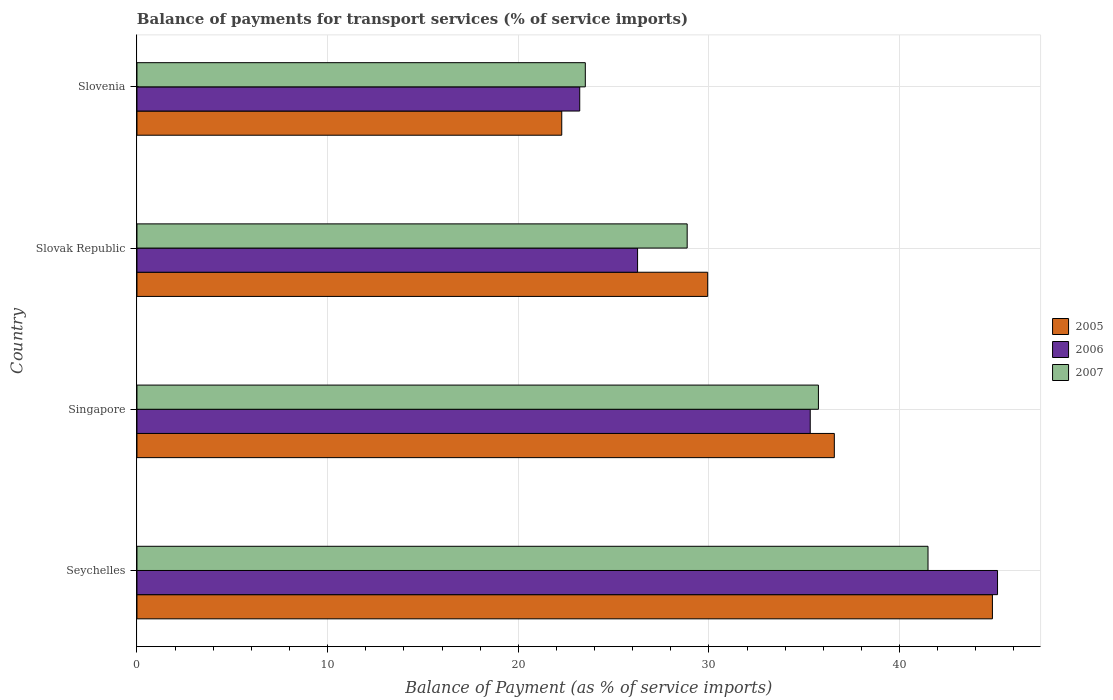How many different coloured bars are there?
Provide a short and direct response. 3. Are the number of bars per tick equal to the number of legend labels?
Offer a terse response. Yes. Are the number of bars on each tick of the Y-axis equal?
Provide a short and direct response. Yes. How many bars are there on the 4th tick from the top?
Offer a very short reply. 3. What is the label of the 1st group of bars from the top?
Your answer should be very brief. Slovenia. In how many cases, is the number of bars for a given country not equal to the number of legend labels?
Make the answer very short. 0. What is the balance of payments for transport services in 2007 in Singapore?
Your answer should be very brief. 35.74. Across all countries, what is the maximum balance of payments for transport services in 2006?
Ensure brevity in your answer.  45.14. Across all countries, what is the minimum balance of payments for transport services in 2007?
Provide a short and direct response. 23.52. In which country was the balance of payments for transport services in 2006 maximum?
Your answer should be very brief. Seychelles. In which country was the balance of payments for transport services in 2006 minimum?
Provide a short and direct response. Slovenia. What is the total balance of payments for transport services in 2007 in the graph?
Give a very brief answer. 129.61. What is the difference between the balance of payments for transport services in 2005 in Seychelles and that in Singapore?
Your response must be concise. 8.29. What is the difference between the balance of payments for transport services in 2005 in Slovak Republic and the balance of payments for transport services in 2006 in Slovenia?
Keep it short and to the point. 6.71. What is the average balance of payments for transport services in 2005 per country?
Offer a terse response. 33.42. What is the difference between the balance of payments for transport services in 2007 and balance of payments for transport services in 2006 in Singapore?
Ensure brevity in your answer.  0.43. In how many countries, is the balance of payments for transport services in 2007 greater than 14 %?
Offer a very short reply. 4. What is the ratio of the balance of payments for transport services in 2006 in Slovak Republic to that in Slovenia?
Your answer should be very brief. 1.13. What is the difference between the highest and the second highest balance of payments for transport services in 2006?
Provide a succinct answer. 9.82. What is the difference between the highest and the lowest balance of payments for transport services in 2005?
Provide a short and direct response. 22.59. In how many countries, is the balance of payments for transport services in 2006 greater than the average balance of payments for transport services in 2006 taken over all countries?
Ensure brevity in your answer.  2. Is it the case that in every country, the sum of the balance of payments for transport services in 2006 and balance of payments for transport services in 2007 is greater than the balance of payments for transport services in 2005?
Your answer should be very brief. Yes. How many countries are there in the graph?
Provide a short and direct response. 4. Where does the legend appear in the graph?
Keep it short and to the point. Center right. How are the legend labels stacked?
Make the answer very short. Vertical. What is the title of the graph?
Keep it short and to the point. Balance of payments for transport services (% of service imports). What is the label or title of the X-axis?
Offer a very short reply. Balance of Payment (as % of service imports). What is the Balance of Payment (as % of service imports) of 2005 in Seychelles?
Your answer should be compact. 44.87. What is the Balance of Payment (as % of service imports) in 2006 in Seychelles?
Your answer should be compact. 45.14. What is the Balance of Payment (as % of service imports) in 2007 in Seychelles?
Your response must be concise. 41.49. What is the Balance of Payment (as % of service imports) in 2005 in Singapore?
Your answer should be very brief. 36.58. What is the Balance of Payment (as % of service imports) in 2006 in Singapore?
Keep it short and to the point. 35.31. What is the Balance of Payment (as % of service imports) of 2007 in Singapore?
Provide a short and direct response. 35.74. What is the Balance of Payment (as % of service imports) of 2005 in Slovak Republic?
Ensure brevity in your answer.  29.93. What is the Balance of Payment (as % of service imports) in 2006 in Slovak Republic?
Make the answer very short. 26.26. What is the Balance of Payment (as % of service imports) of 2007 in Slovak Republic?
Offer a very short reply. 28.86. What is the Balance of Payment (as % of service imports) of 2005 in Slovenia?
Ensure brevity in your answer.  22.28. What is the Balance of Payment (as % of service imports) of 2006 in Slovenia?
Offer a terse response. 23.22. What is the Balance of Payment (as % of service imports) in 2007 in Slovenia?
Offer a terse response. 23.52. Across all countries, what is the maximum Balance of Payment (as % of service imports) of 2005?
Ensure brevity in your answer.  44.87. Across all countries, what is the maximum Balance of Payment (as % of service imports) in 2006?
Your answer should be compact. 45.14. Across all countries, what is the maximum Balance of Payment (as % of service imports) in 2007?
Your answer should be compact. 41.49. Across all countries, what is the minimum Balance of Payment (as % of service imports) in 2005?
Give a very brief answer. 22.28. Across all countries, what is the minimum Balance of Payment (as % of service imports) in 2006?
Your answer should be very brief. 23.22. Across all countries, what is the minimum Balance of Payment (as % of service imports) in 2007?
Your answer should be very brief. 23.52. What is the total Balance of Payment (as % of service imports) in 2005 in the graph?
Ensure brevity in your answer.  133.66. What is the total Balance of Payment (as % of service imports) of 2006 in the graph?
Provide a short and direct response. 129.93. What is the total Balance of Payment (as % of service imports) in 2007 in the graph?
Offer a very short reply. 129.61. What is the difference between the Balance of Payment (as % of service imports) of 2005 in Seychelles and that in Singapore?
Offer a terse response. 8.29. What is the difference between the Balance of Payment (as % of service imports) in 2006 in Seychelles and that in Singapore?
Ensure brevity in your answer.  9.82. What is the difference between the Balance of Payment (as % of service imports) of 2007 in Seychelles and that in Singapore?
Keep it short and to the point. 5.75. What is the difference between the Balance of Payment (as % of service imports) of 2005 in Seychelles and that in Slovak Republic?
Ensure brevity in your answer.  14.94. What is the difference between the Balance of Payment (as % of service imports) in 2006 in Seychelles and that in Slovak Republic?
Provide a short and direct response. 18.88. What is the difference between the Balance of Payment (as % of service imports) of 2007 in Seychelles and that in Slovak Republic?
Your response must be concise. 12.63. What is the difference between the Balance of Payment (as % of service imports) of 2005 in Seychelles and that in Slovenia?
Provide a short and direct response. 22.59. What is the difference between the Balance of Payment (as % of service imports) of 2006 in Seychelles and that in Slovenia?
Provide a succinct answer. 21.91. What is the difference between the Balance of Payment (as % of service imports) of 2007 in Seychelles and that in Slovenia?
Offer a terse response. 17.98. What is the difference between the Balance of Payment (as % of service imports) of 2005 in Singapore and that in Slovak Republic?
Your answer should be very brief. 6.64. What is the difference between the Balance of Payment (as % of service imports) in 2006 in Singapore and that in Slovak Republic?
Offer a very short reply. 9.06. What is the difference between the Balance of Payment (as % of service imports) in 2007 in Singapore and that in Slovak Republic?
Your answer should be very brief. 6.88. What is the difference between the Balance of Payment (as % of service imports) in 2005 in Singapore and that in Slovenia?
Keep it short and to the point. 14.3. What is the difference between the Balance of Payment (as % of service imports) of 2006 in Singapore and that in Slovenia?
Make the answer very short. 12.09. What is the difference between the Balance of Payment (as % of service imports) of 2007 in Singapore and that in Slovenia?
Your answer should be compact. 12.23. What is the difference between the Balance of Payment (as % of service imports) in 2005 in Slovak Republic and that in Slovenia?
Give a very brief answer. 7.65. What is the difference between the Balance of Payment (as % of service imports) in 2006 in Slovak Republic and that in Slovenia?
Your response must be concise. 3.03. What is the difference between the Balance of Payment (as % of service imports) in 2007 in Slovak Republic and that in Slovenia?
Provide a succinct answer. 5.34. What is the difference between the Balance of Payment (as % of service imports) in 2005 in Seychelles and the Balance of Payment (as % of service imports) in 2006 in Singapore?
Provide a succinct answer. 9.56. What is the difference between the Balance of Payment (as % of service imports) in 2005 in Seychelles and the Balance of Payment (as % of service imports) in 2007 in Singapore?
Make the answer very short. 9.13. What is the difference between the Balance of Payment (as % of service imports) of 2006 in Seychelles and the Balance of Payment (as % of service imports) of 2007 in Singapore?
Your answer should be very brief. 9.39. What is the difference between the Balance of Payment (as % of service imports) in 2005 in Seychelles and the Balance of Payment (as % of service imports) in 2006 in Slovak Republic?
Your answer should be compact. 18.61. What is the difference between the Balance of Payment (as % of service imports) of 2005 in Seychelles and the Balance of Payment (as % of service imports) of 2007 in Slovak Republic?
Offer a terse response. 16.01. What is the difference between the Balance of Payment (as % of service imports) in 2006 in Seychelles and the Balance of Payment (as % of service imports) in 2007 in Slovak Republic?
Your answer should be compact. 16.28. What is the difference between the Balance of Payment (as % of service imports) of 2005 in Seychelles and the Balance of Payment (as % of service imports) of 2006 in Slovenia?
Your response must be concise. 21.65. What is the difference between the Balance of Payment (as % of service imports) of 2005 in Seychelles and the Balance of Payment (as % of service imports) of 2007 in Slovenia?
Offer a very short reply. 21.35. What is the difference between the Balance of Payment (as % of service imports) of 2006 in Seychelles and the Balance of Payment (as % of service imports) of 2007 in Slovenia?
Your response must be concise. 21.62. What is the difference between the Balance of Payment (as % of service imports) of 2005 in Singapore and the Balance of Payment (as % of service imports) of 2006 in Slovak Republic?
Ensure brevity in your answer.  10.32. What is the difference between the Balance of Payment (as % of service imports) of 2005 in Singapore and the Balance of Payment (as % of service imports) of 2007 in Slovak Republic?
Ensure brevity in your answer.  7.72. What is the difference between the Balance of Payment (as % of service imports) of 2006 in Singapore and the Balance of Payment (as % of service imports) of 2007 in Slovak Republic?
Provide a succinct answer. 6.46. What is the difference between the Balance of Payment (as % of service imports) of 2005 in Singapore and the Balance of Payment (as % of service imports) of 2006 in Slovenia?
Provide a short and direct response. 13.35. What is the difference between the Balance of Payment (as % of service imports) of 2005 in Singapore and the Balance of Payment (as % of service imports) of 2007 in Slovenia?
Your response must be concise. 13.06. What is the difference between the Balance of Payment (as % of service imports) in 2006 in Singapore and the Balance of Payment (as % of service imports) in 2007 in Slovenia?
Your answer should be very brief. 11.8. What is the difference between the Balance of Payment (as % of service imports) in 2005 in Slovak Republic and the Balance of Payment (as % of service imports) in 2006 in Slovenia?
Make the answer very short. 6.71. What is the difference between the Balance of Payment (as % of service imports) in 2005 in Slovak Republic and the Balance of Payment (as % of service imports) in 2007 in Slovenia?
Your answer should be very brief. 6.42. What is the difference between the Balance of Payment (as % of service imports) in 2006 in Slovak Republic and the Balance of Payment (as % of service imports) in 2007 in Slovenia?
Ensure brevity in your answer.  2.74. What is the average Balance of Payment (as % of service imports) in 2005 per country?
Give a very brief answer. 33.42. What is the average Balance of Payment (as % of service imports) in 2006 per country?
Provide a succinct answer. 32.48. What is the average Balance of Payment (as % of service imports) in 2007 per country?
Provide a short and direct response. 32.4. What is the difference between the Balance of Payment (as % of service imports) of 2005 and Balance of Payment (as % of service imports) of 2006 in Seychelles?
Give a very brief answer. -0.27. What is the difference between the Balance of Payment (as % of service imports) of 2005 and Balance of Payment (as % of service imports) of 2007 in Seychelles?
Your answer should be compact. 3.38. What is the difference between the Balance of Payment (as % of service imports) in 2006 and Balance of Payment (as % of service imports) in 2007 in Seychelles?
Offer a terse response. 3.65. What is the difference between the Balance of Payment (as % of service imports) in 2005 and Balance of Payment (as % of service imports) in 2006 in Singapore?
Offer a very short reply. 1.26. What is the difference between the Balance of Payment (as % of service imports) in 2005 and Balance of Payment (as % of service imports) in 2007 in Singapore?
Provide a succinct answer. 0.83. What is the difference between the Balance of Payment (as % of service imports) in 2006 and Balance of Payment (as % of service imports) in 2007 in Singapore?
Your response must be concise. -0.43. What is the difference between the Balance of Payment (as % of service imports) of 2005 and Balance of Payment (as % of service imports) of 2006 in Slovak Republic?
Keep it short and to the point. 3.68. What is the difference between the Balance of Payment (as % of service imports) in 2005 and Balance of Payment (as % of service imports) in 2007 in Slovak Republic?
Offer a very short reply. 1.08. What is the difference between the Balance of Payment (as % of service imports) of 2006 and Balance of Payment (as % of service imports) of 2007 in Slovak Republic?
Your response must be concise. -2.6. What is the difference between the Balance of Payment (as % of service imports) of 2005 and Balance of Payment (as % of service imports) of 2006 in Slovenia?
Give a very brief answer. -0.94. What is the difference between the Balance of Payment (as % of service imports) of 2005 and Balance of Payment (as % of service imports) of 2007 in Slovenia?
Provide a short and direct response. -1.24. What is the difference between the Balance of Payment (as % of service imports) of 2006 and Balance of Payment (as % of service imports) of 2007 in Slovenia?
Offer a terse response. -0.29. What is the ratio of the Balance of Payment (as % of service imports) in 2005 in Seychelles to that in Singapore?
Your answer should be very brief. 1.23. What is the ratio of the Balance of Payment (as % of service imports) in 2006 in Seychelles to that in Singapore?
Ensure brevity in your answer.  1.28. What is the ratio of the Balance of Payment (as % of service imports) in 2007 in Seychelles to that in Singapore?
Your answer should be compact. 1.16. What is the ratio of the Balance of Payment (as % of service imports) in 2005 in Seychelles to that in Slovak Republic?
Keep it short and to the point. 1.5. What is the ratio of the Balance of Payment (as % of service imports) in 2006 in Seychelles to that in Slovak Republic?
Ensure brevity in your answer.  1.72. What is the ratio of the Balance of Payment (as % of service imports) in 2007 in Seychelles to that in Slovak Republic?
Offer a very short reply. 1.44. What is the ratio of the Balance of Payment (as % of service imports) in 2005 in Seychelles to that in Slovenia?
Your response must be concise. 2.01. What is the ratio of the Balance of Payment (as % of service imports) of 2006 in Seychelles to that in Slovenia?
Make the answer very short. 1.94. What is the ratio of the Balance of Payment (as % of service imports) in 2007 in Seychelles to that in Slovenia?
Your answer should be compact. 1.76. What is the ratio of the Balance of Payment (as % of service imports) of 2005 in Singapore to that in Slovak Republic?
Offer a very short reply. 1.22. What is the ratio of the Balance of Payment (as % of service imports) in 2006 in Singapore to that in Slovak Republic?
Ensure brevity in your answer.  1.34. What is the ratio of the Balance of Payment (as % of service imports) in 2007 in Singapore to that in Slovak Republic?
Make the answer very short. 1.24. What is the ratio of the Balance of Payment (as % of service imports) of 2005 in Singapore to that in Slovenia?
Your answer should be very brief. 1.64. What is the ratio of the Balance of Payment (as % of service imports) in 2006 in Singapore to that in Slovenia?
Provide a short and direct response. 1.52. What is the ratio of the Balance of Payment (as % of service imports) of 2007 in Singapore to that in Slovenia?
Make the answer very short. 1.52. What is the ratio of the Balance of Payment (as % of service imports) of 2005 in Slovak Republic to that in Slovenia?
Ensure brevity in your answer.  1.34. What is the ratio of the Balance of Payment (as % of service imports) of 2006 in Slovak Republic to that in Slovenia?
Provide a short and direct response. 1.13. What is the ratio of the Balance of Payment (as % of service imports) of 2007 in Slovak Republic to that in Slovenia?
Your answer should be compact. 1.23. What is the difference between the highest and the second highest Balance of Payment (as % of service imports) of 2005?
Give a very brief answer. 8.29. What is the difference between the highest and the second highest Balance of Payment (as % of service imports) of 2006?
Make the answer very short. 9.82. What is the difference between the highest and the second highest Balance of Payment (as % of service imports) in 2007?
Offer a terse response. 5.75. What is the difference between the highest and the lowest Balance of Payment (as % of service imports) in 2005?
Offer a terse response. 22.59. What is the difference between the highest and the lowest Balance of Payment (as % of service imports) of 2006?
Give a very brief answer. 21.91. What is the difference between the highest and the lowest Balance of Payment (as % of service imports) of 2007?
Your response must be concise. 17.98. 